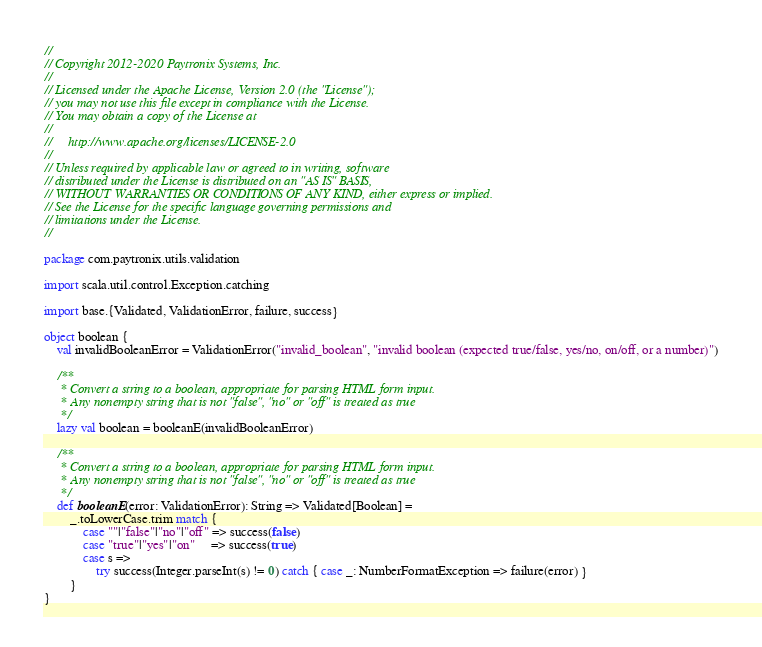Convert code to text. <code><loc_0><loc_0><loc_500><loc_500><_Scala_>//
// Copyright 2012-2020 Paytronix Systems, Inc.
//
// Licensed under the Apache License, Version 2.0 (the "License");
// you may not use this file except in compliance with the License.
// You may obtain a copy of the License at
//
//     http://www.apache.org/licenses/LICENSE-2.0
//
// Unless required by applicable law or agreed to in writing, software
// distributed under the License is distributed on an "AS IS" BASIS,
// WITHOUT WARRANTIES OR CONDITIONS OF ANY KIND, either express or implied.
// See the License for the specific language governing permissions and
// limitations under the License.
//

package com.paytronix.utils.validation

import scala.util.control.Exception.catching

import base.{Validated, ValidationError, failure, success}

object boolean {
    val invalidBooleanError = ValidationError("invalid_boolean", "invalid boolean (expected true/false, yes/no, on/off, or a number)")

    /**
     * Convert a string to a boolean, appropriate for parsing HTML form input.
     * Any nonempty string that is not "false", "no" or "off" is treated as true
     */
    lazy val boolean = booleanE(invalidBooleanError)

    /**
     * Convert a string to a boolean, appropriate for parsing HTML form input.
     * Any nonempty string that is not "false", "no" or "off" is treated as true
     */
    def booleanE(error: ValidationError): String => Validated[Boolean] =
        _.toLowerCase.trim match {
            case ""|"false"|"no"|"off" => success(false)
            case "true"|"yes"|"on"     => success(true)
            case s =>
                try success(Integer.parseInt(s) != 0) catch { case _: NumberFormatException => failure(error) }
        }
}

</code> 